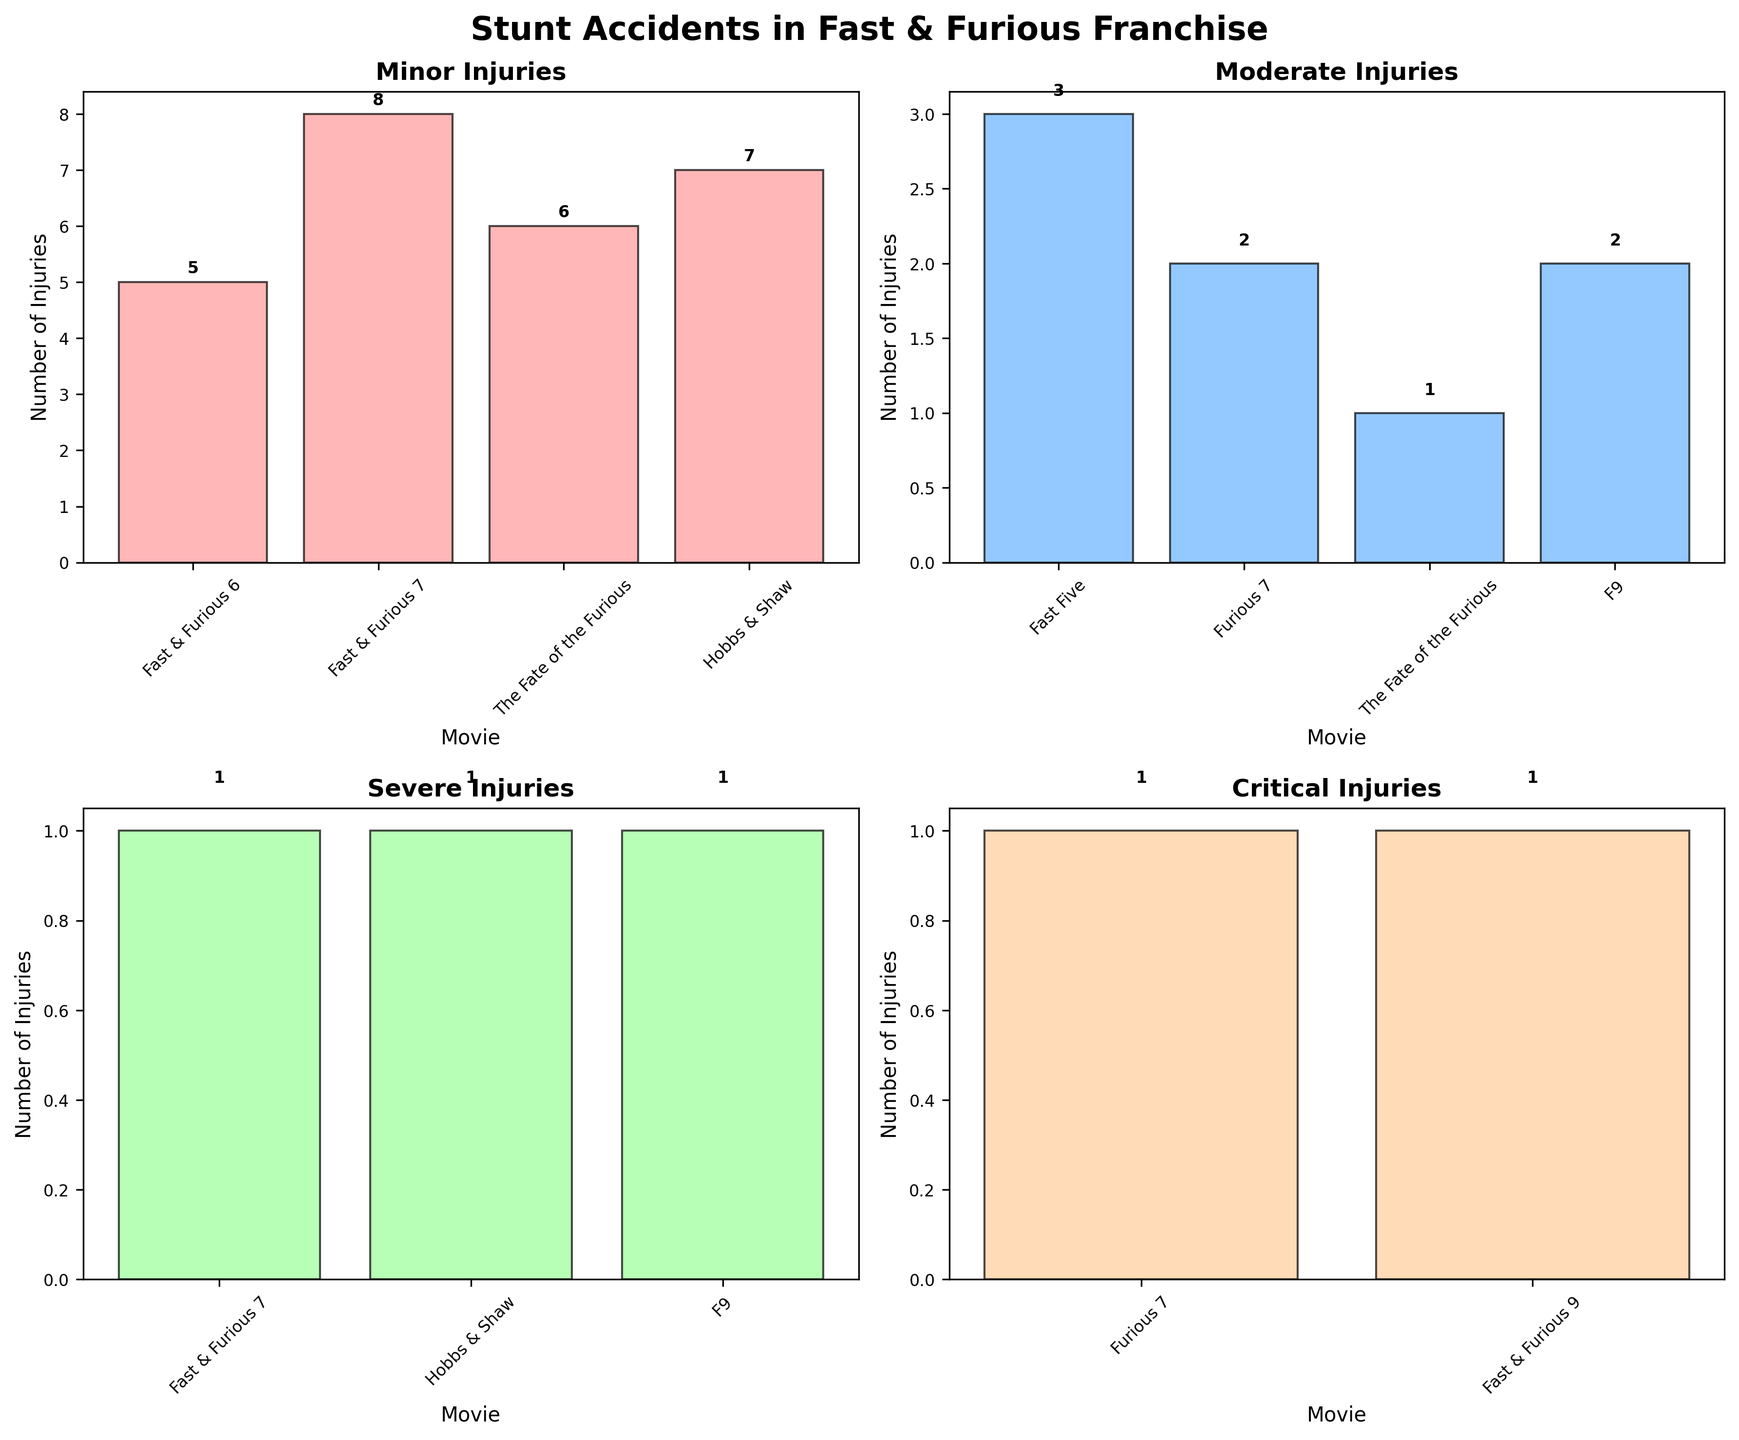What is the title of the figure? The title of the figure is shown at the top center of the image where it is printed in bold text for emphasis.
Answer: Stunt Accidents in Fast & Furious Franchise How many injuries were reported in "Fast & Furious 7" for minor injuries? To determine this, locate the subplot for "Minor Injuries" and find the bar labeled "Fast & Furious 7". The height of the bar, along with the labeled number on it, represents the number of injuries.
Answer: 8 Which movie has the highest number of moderate injuries? To find the answer, look at the subplot titled "Moderate Injuries" and compare the heights of the bars. The tallest bar indicates the movie with the highest number of moderate injuries.
Answer: Fast Five What is the total number of critical injuries across all movies? Sum the number of injuries from the bars in the subplot labeled "Critical Injuries". The bars represent the movies and the numbers are the injuries.
Answer: 2 How many more minor injuries occurred in "Fast & Furious 7" compared to "The Fate of the Furious"? Refer to the "Minor Injuries" subplot and find the bars for "Fast & Furious 7" and "The Fate of the Furious". Subtract the number of injuries in "The Fate of the Furious" from that in "Fast & Furious 7".
Answer: 8 - 6 = 2 Which severity category has the most movies with reported injuries? Count the number of bars (each representing a movie) in each of the four subplots titled "Minor Injuries", "Moderate Injuries", "Severe Injuries", and "Critical Injuries". The subplot with the most bars indicates the category.
Answer: Minor (4 movies) What is the average number of severe injuries per movie? Calculate the total of severe injuries by summing the values in the "Severe Injuries" subplot, and divide by the number of movies with severe injuries (indicated by the number of bars).
Answer: (1 + 1 + 1) / 3 = 1 Comparing "Furious 7" and "Hobbs & Shaw", which one had more severe injuries? Refer to the "Severe Injuries" subplot and compare the heights of the bars for "Furious 7" and "Hobbs & Shaw". The bar with the greater height represents the higher number of injuries.
Answer: Both had the same (1) What's the difference in the number of moderate injuries between "Fast Five" and "The Fate of the Furious"? Look at the "Moderate Injuries" subplot and subtract the injuries in "The Fate of the Furious" from those in "Fast Five".
Answer: 3 - 1 = 2 